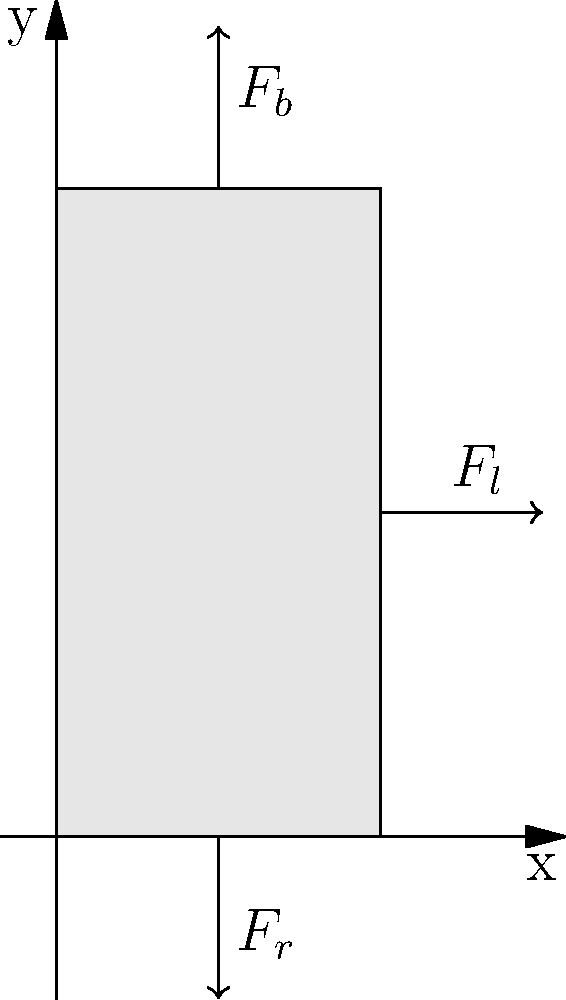In the context of eating disorders, understanding the biomechanics of chewing is crucial. Consider the forces acting on a tooth during biting and grinding, as shown in the vector diagram. The biting force $F_b$ is 200 N, the reactive force from the jaw $F_r$ is 180 N, and the lateral force from grinding $F_l$ is 50 N. Calculate the magnitude of the resultant force vector acting on the tooth. To solve this problem, we'll follow these steps:

1) Identify the forces:
   $F_b$ (biting force) = 200 N, acting in the positive y-direction
   $F_r$ (reactive force) = 180 N, acting in the negative y-direction
   $F_l$ (lateral force) = 50 N, acting in the positive x-direction

2) Calculate the net force in the y-direction:
   $F_y = F_b - F_r = 200 N - 180 N = 20 N$

3) The force in the x-direction is simply $F_l$:
   $F_x = F_l = 50 N$

4) The resultant force can be calculated using the Pythagorean theorem:
   $F_{resultant} = \sqrt{F_x^2 + F_y^2}$

5) Substitute the values:
   $F_{resultant} = \sqrt{(50 N)^2 + (20 N)^2}$

6) Calculate:
   $F_{resultant} = \sqrt{2500 N^2 + 400 N^2} = \sqrt{2900 N^2} \approx 53.85 N$

Therefore, the magnitude of the resultant force vector acting on the tooth is approximately 53.85 N.
Answer: 53.85 N 